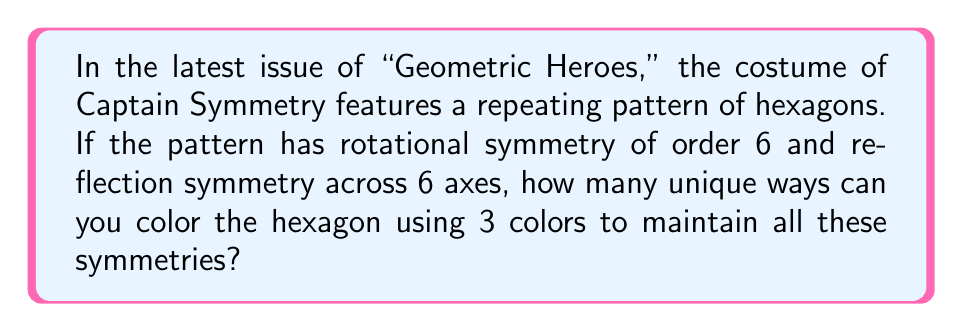Solve this math problem. Let's approach this step-by-step:

1) First, let's visualize the hexagon:

[asy]
unitsize(1cm);
for(int i=0; i<6; i++) {
  draw(rotate(60*i)*(1,0)--(cos(pi/3),sin(pi/3)));
}
[/asy]

2) The hexagon has 6-fold rotational symmetry and 6 reflection axes. To maintain these symmetries, we need to color the hexagon in a way that respects these properties.

3) Let's divide the hexagon into 6 equal triangular sectors:

[asy]
unitsize(1cm);
for(int i=0; i<6; i++) {
  draw(rotate(60*i)*(1,0)--(cos(pi/3),sin(pi/3)));
  draw((0,0)--rotate(60*i)*(1,0));
}
[/asy]

4) To maintain rotational symmetry, all sectors must be colored identically.

5) To maintain reflection symmetry, the color pattern within each sector must be symmetric about its central radius.

6) Given these constraints, we have three options for coloring each sector:
   a) All one color
   b) Two colors, with the dividing line along the central radius
   c) Three colors, with two equal areas on either side of the central radius

7) We can represent these options mathematically:
   $$\text{Number of ways} = 3 + \binom{3}{2} + \binom{3}{1} = 3 + 3 + 3 = 9$$

   Where:
   - 3 represents the single color options
   - $\binom{3}{2}$ represents the two-color options
   - $\binom{3}{1}$ represents the three-color options

Therefore, there are 9 unique ways to color the hexagon while maintaining all symmetries.
Answer: 9 